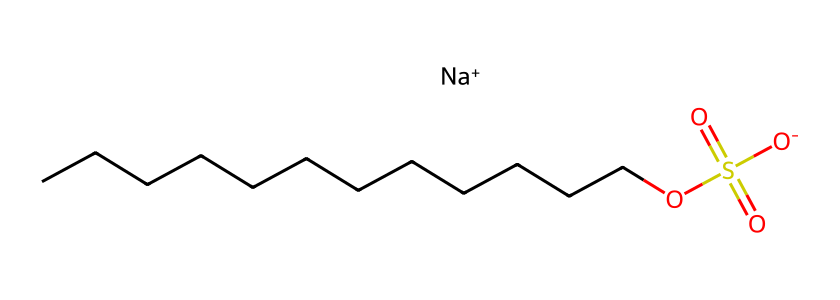What is the total number of carbon atoms in this molecule? The SMILES representation contains "CCCCCCCCCCCC," indicating there are twelve carbon atoms connected in a chain. Thus, we count each "C" in the string to determine the total.
Answer: twelve What type of functional group is present in this chemical? The presence of "OS(=O)(=O)[O-]" indicates the presence of a sulfonate functional group (-SO3^-), which is characteristic of detergents and surfactants.
Answer: sulfonate How many hydrogen atoms are likely connected to the carbon atoms in this molecule? Each of the twelve carbon atoms typically bonds with enough hydrogen atoms to satisfy carbon's tetravalency. Therefore, for saturated hydrocarbon chains, the general formula can be utilized (C_nH_(2n+1) for alkanes plus accounting for the sulfate group). The answer is calculated as 25 hydrogen atoms.
Answer: twenty-five Identify the counterion in this chemical structure. The "Na+" at the end of the SMILES notation represents sodium, which acts as a counterion to balance the negative charge from the sulfonate group.
Answer: sodium Why is this molecule likely effective as a detergent? This molecule's long hydrocarbon chain (the "CCCCCCCCCCCC" portion) allows it to interact with grease and oil, while the sulfonate group promotes solubility in water, making it effective in cleaning. This combination is typical of surfactants, which decrease surface tension and improve cleaning efficacy.
Answer: surfactant 